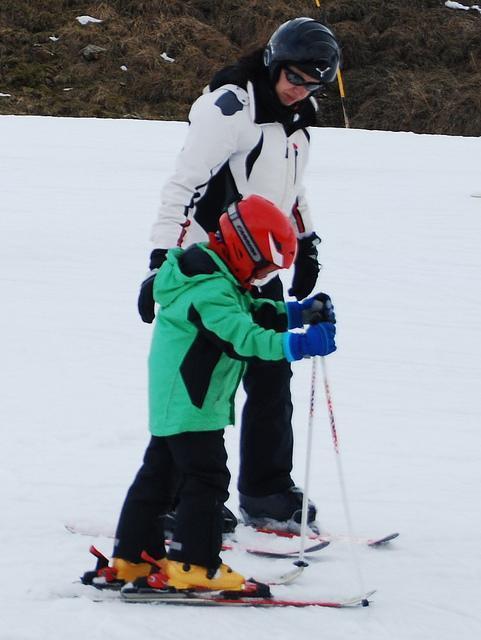Why are his skis so small?
Make your selection from the four choices given to correctly answer the question.
Options: Are broken, is new, is child, someone else's. Is child. 